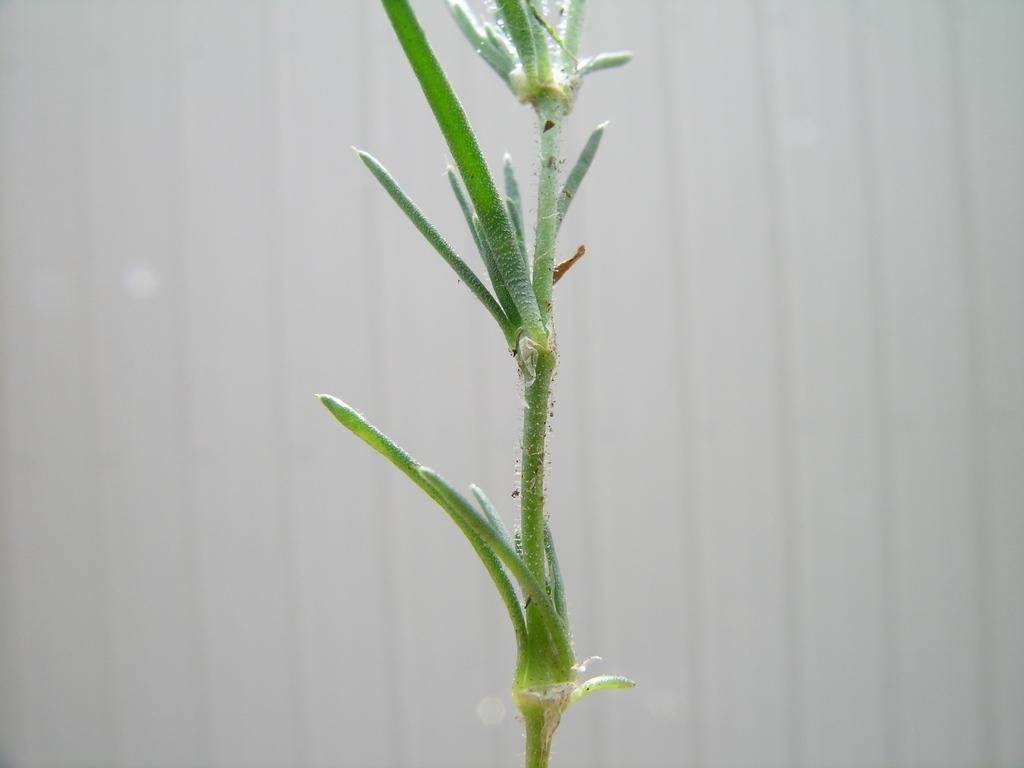In one or two sentences, can you explain what this image depicts? In the image we can see there is a plant. 